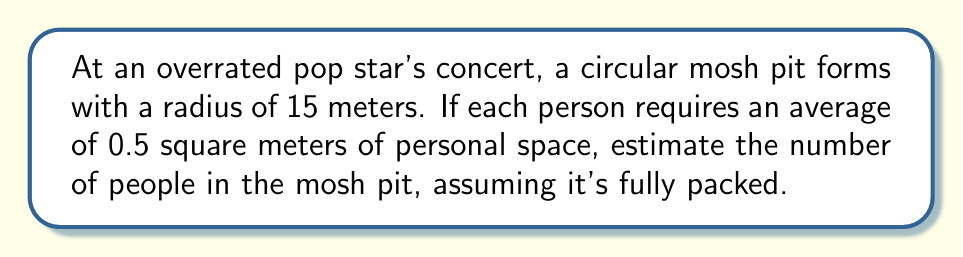Give your solution to this math problem. To solve this problem, we'll follow these steps:

1. Calculate the area of the circular mosh pit:
   The area of a circle is given by the formula $A = \pi r^2$
   $$A = \pi (15\text{ m})^2 = 225\pi \text{ m}^2$$

2. Convert the personal space requirement to square meters:
   Each person needs 0.5 square meters of space.

3. Calculate the number of people that can fit in the mosh pit:
   Number of people = Total area / Area per person
   $$\text{Number of people} = \frac{225\pi \text{ m}^2}{0.5 \text{ m}^2/\text{person}}$$
   $$= 450\pi \text{ people}$$

4. Evaluate the expression:
   $$450\pi \approx 1,413.72 \text{ people}$$

5. Round to the nearest whole number:
   Approximately 1,414 people can fit in the mosh pit.

[asy]
import geometry;

size(200);
real r = 15;
draw(circle((0,0),r));
draw((-r,0)--(r,0),dashed);
label("30m", (r,0), E);
label("15m", (r/2,0), N);

for(int i = 0; i < 20; ++i) {
  for(int j = 0; j < 20; ++j) {
    real x = (i-10)/2;
    real y = (j-10)/2;
    if(x^2 + y^2 <= r^2) {
      dot((x,y));
    }
  }
}
[/asy]
Answer: 1,414 people 